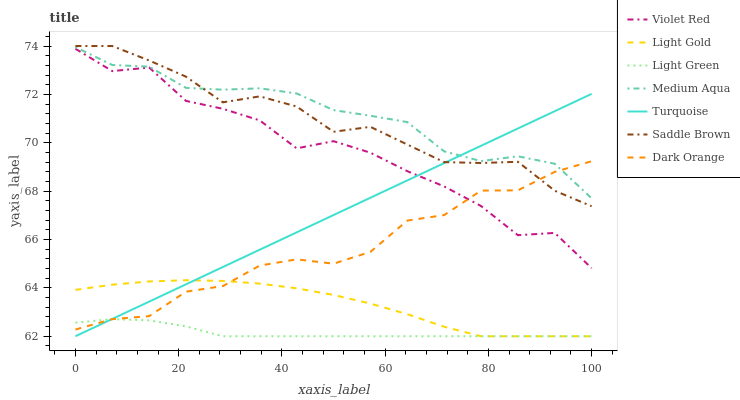Does Light Green have the minimum area under the curve?
Answer yes or no. Yes. Does Medium Aqua have the maximum area under the curve?
Answer yes or no. Yes. Does Violet Red have the minimum area under the curve?
Answer yes or no. No. Does Violet Red have the maximum area under the curve?
Answer yes or no. No. Is Turquoise the smoothest?
Answer yes or no. Yes. Is Violet Red the roughest?
Answer yes or no. Yes. Is Violet Red the smoothest?
Answer yes or no. No. Is Turquoise the roughest?
Answer yes or no. No. Does Turquoise have the lowest value?
Answer yes or no. Yes. Does Violet Red have the lowest value?
Answer yes or no. No. Does Saddle Brown have the highest value?
Answer yes or no. Yes. Does Violet Red have the highest value?
Answer yes or no. No. Is Light Gold less than Saddle Brown?
Answer yes or no. Yes. Is Medium Aqua greater than Violet Red?
Answer yes or no. Yes. Does Violet Red intersect Turquoise?
Answer yes or no. Yes. Is Violet Red less than Turquoise?
Answer yes or no. No. Is Violet Red greater than Turquoise?
Answer yes or no. No. Does Light Gold intersect Saddle Brown?
Answer yes or no. No. 